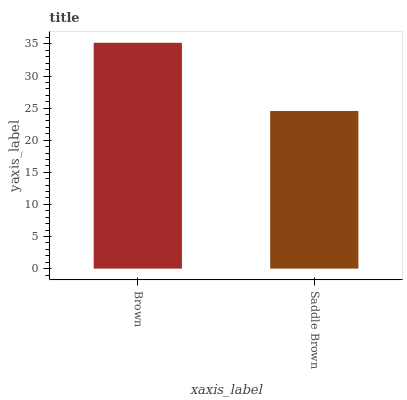Is Saddle Brown the minimum?
Answer yes or no. Yes. Is Brown the maximum?
Answer yes or no. Yes. Is Saddle Brown the maximum?
Answer yes or no. No. Is Brown greater than Saddle Brown?
Answer yes or no. Yes. Is Saddle Brown less than Brown?
Answer yes or no. Yes. Is Saddle Brown greater than Brown?
Answer yes or no. No. Is Brown less than Saddle Brown?
Answer yes or no. No. Is Brown the high median?
Answer yes or no. Yes. Is Saddle Brown the low median?
Answer yes or no. Yes. Is Saddle Brown the high median?
Answer yes or no. No. Is Brown the low median?
Answer yes or no. No. 